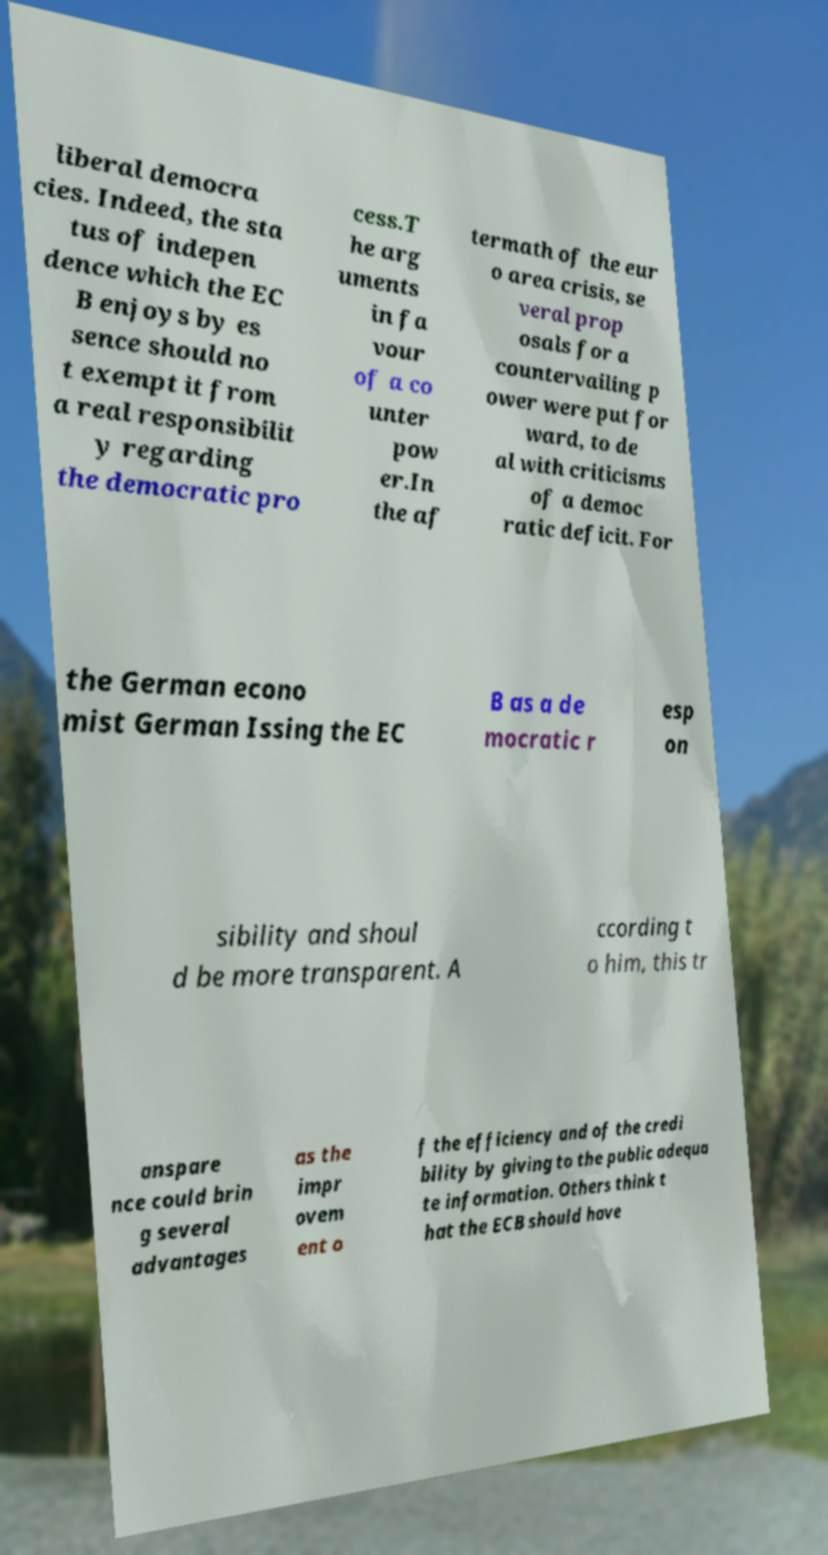Could you extract and type out the text from this image? liberal democra cies. Indeed, the sta tus of indepen dence which the EC B enjoys by es sence should no t exempt it from a real responsibilit y regarding the democratic pro cess.T he arg uments in fa vour of a co unter pow er.In the af termath of the eur o area crisis, se veral prop osals for a countervailing p ower were put for ward, to de al with criticisms of a democ ratic deficit. For the German econo mist German Issing the EC B as a de mocratic r esp on sibility and shoul d be more transparent. A ccording t o him, this tr anspare nce could brin g several advantages as the impr ovem ent o f the efficiency and of the credi bility by giving to the public adequa te information. Others think t hat the ECB should have 